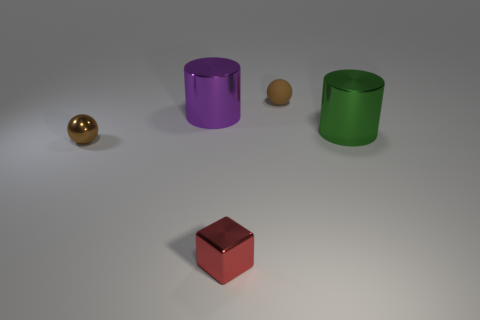Subtract all purple cylinders. How many cylinders are left? 1 Add 2 tiny balls. How many objects exist? 7 Add 5 small objects. How many small objects are left? 8 Add 2 tiny red shiny blocks. How many tiny red shiny blocks exist? 3 Subtract 0 cyan spheres. How many objects are left? 5 Subtract all blocks. How many objects are left? 4 Subtract 1 balls. How many balls are left? 1 Subtract all brown cubes. Subtract all cyan cylinders. How many cubes are left? 1 Subtract all green cylinders. How many blue blocks are left? 0 Subtract all brown shiny objects. Subtract all metal things. How many objects are left? 0 